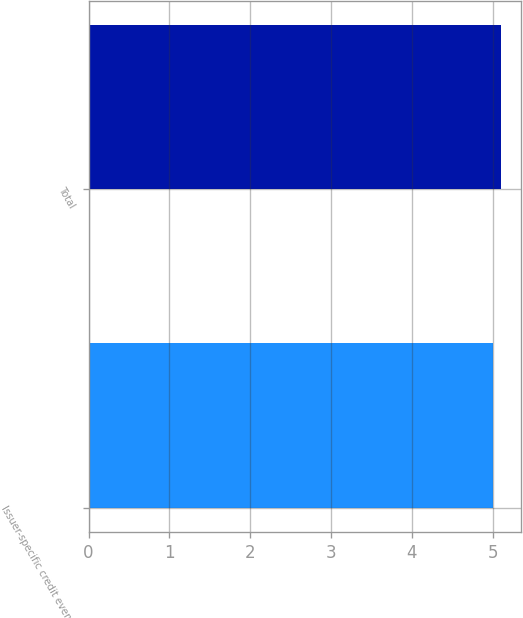Convert chart to OTSL. <chart><loc_0><loc_0><loc_500><loc_500><bar_chart><fcel>Issuer-specific credit events<fcel>Total<nl><fcel>5<fcel>5.1<nl></chart> 